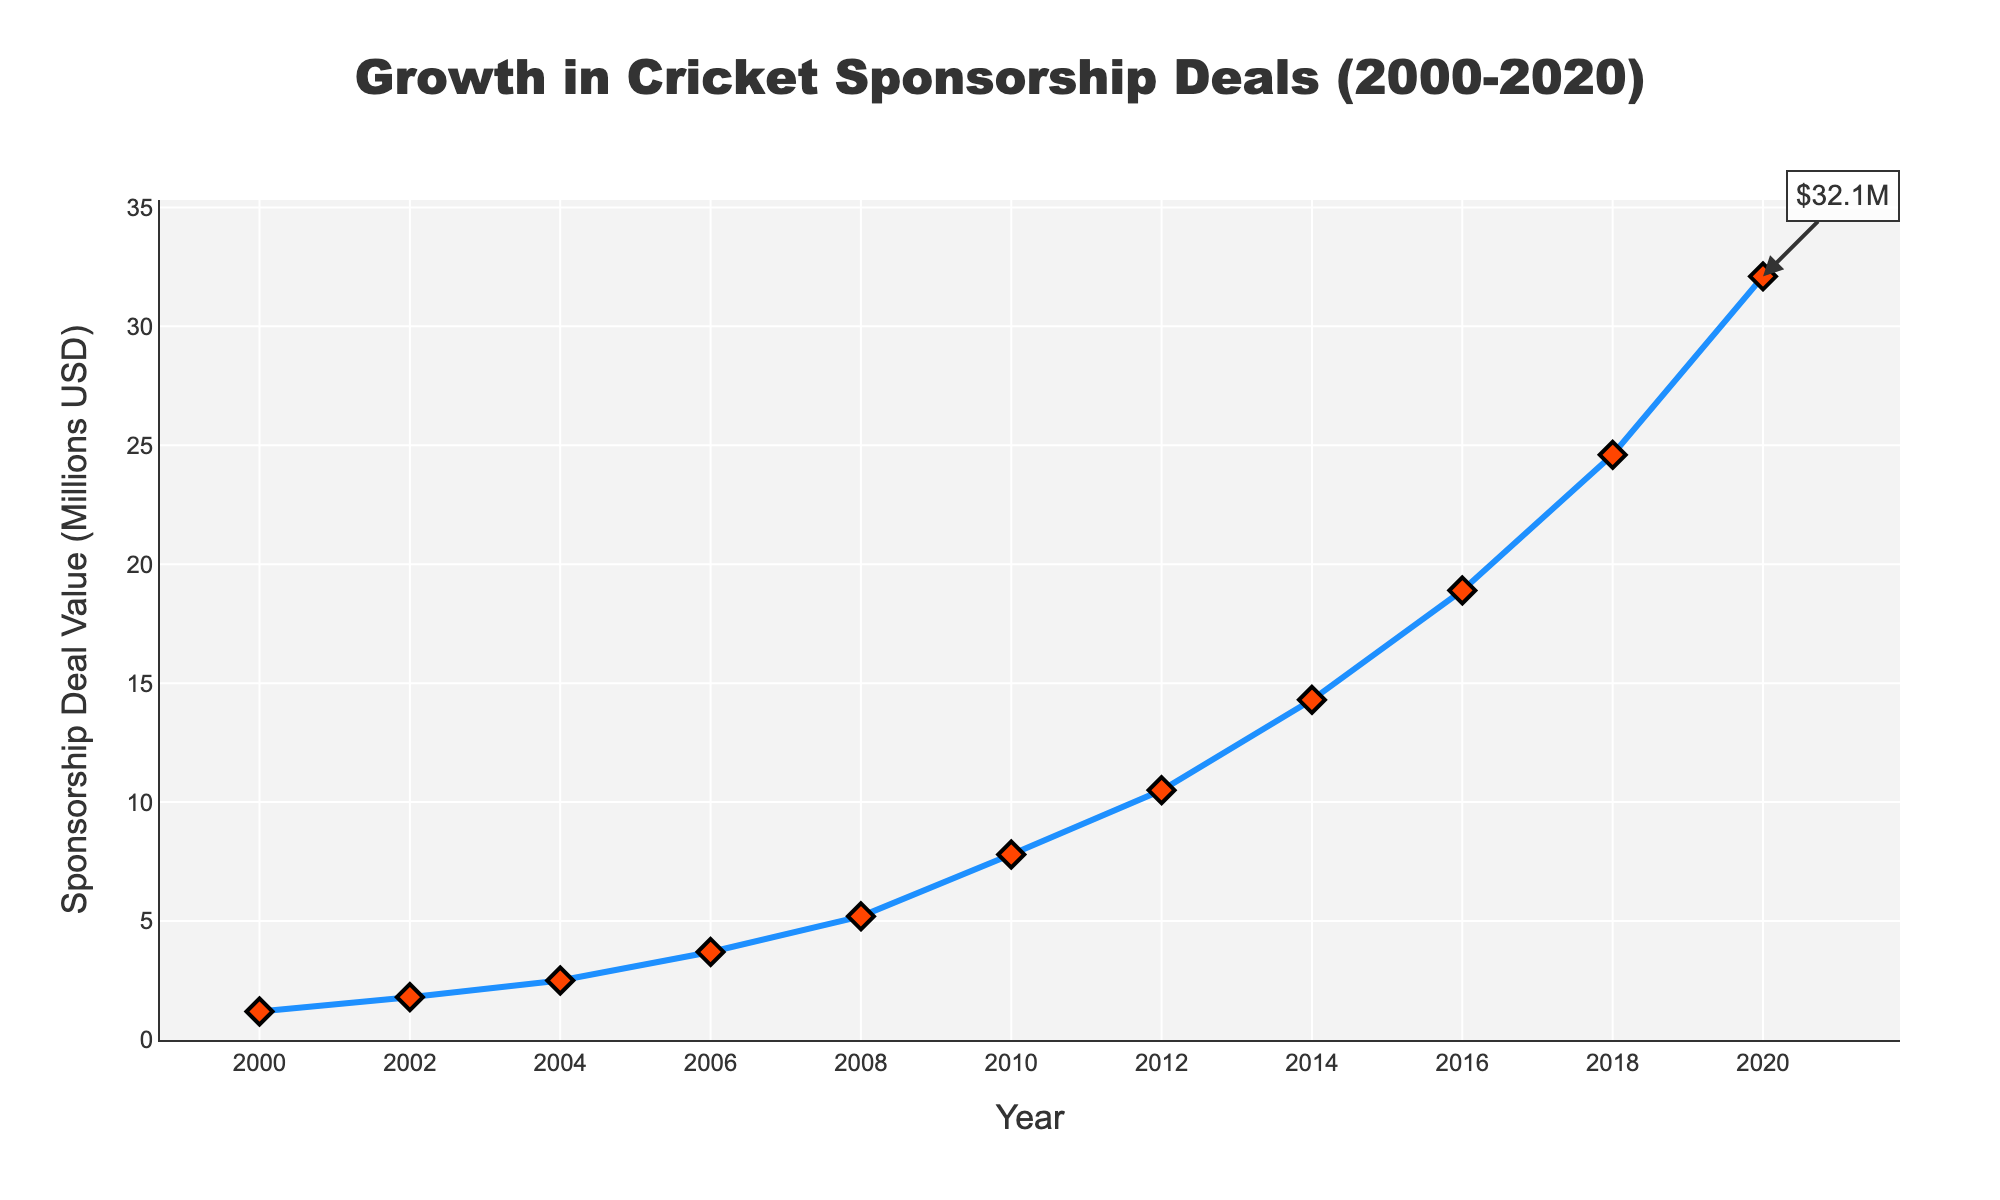What is the value of the sponsorship deals in 2008 and how does it compare to 2010? In 2008, the value of the sponsorship deals is $5.2M. In 2010, it is $7.8M. Comparing these, the sponsorship deals value increased by $2.6M from 2008 to 2010.
Answer: In 2008: $5.2M, In 2010: $7.8M, Increase by $2.6M What was the total growth in sponsorship deal value from 2000 to 2020? The value in 2000 was $1.2M and in 2020 it was $32.1M. The total growth is calculated by subtracting the 2000 value from the 2020 value: $32.1M - $1.2M = $30.9M.
Answer: $30.9M What is the average annual increase in sponsorship deal value between 2000 and 2020? First, calculate the total increase, which is $30.9M, and then divide it by the number of years (2020 - 2000 = 20 years). The average annual increase is $30.9M / 20 years = $1.545M per year.
Answer: $1.545M per year How does the sponsorship deal value in 2016 compare to the previous four years combined? The value in 2016 was $18.9M. The combined value of the four previous years (2012 and 2014 only, as data is biennial) is $10.5M (2012) + $14.3M (2014) = $24.8M. The value in 2016 is less than the combined values of the previous four years.
Answer: 2016: $18.9M, Previous four years combined: $24.8M, 2016 is less Which year saw the highest growth in sponsorship deal value, and what was the value increase? The highest growth is observed between 2018 ($24.6M) and 2020 ($32.1M). The value increase is $32.1M - $24.6M = $7.5M.
Answer: 2018-2020, $7.5M What was the percentage increase in sponsorship deal value from 2014 to 2016? The value in 2014 was $14.3M and in 2016 it was $18.9M. The percentage increase is calculated as (($18.9M - $14.3M) / $14.3M) * 100 = 32.17%.
Answer: 32.17% Would you say the sponsorship deal value grew more consistently in the first decade (2000-2010) or the second decade (2010-2020)? In the first decade, the values grew from $1.2M in 2000 to $7.8M in 2010, a difference of $6.6M over 10 years. In the second decade, the values grew from $7.8M in 2010 to $32.1M in 2020, a difference of $24.3M. The second decade shows a more significant and consistent growth.
Answer: Second decade, $24.3M What is the median sponsorship deal value over the 20-year period? The median sponsorship deal value is the middle value when the data points are ordered. The ordered values are: 1.2, 1.8, 2.5, 3.7, 5.2, 7.8, 10.5, 14.3, 18.9, 24.6, 32.1. As there is an odd number of data points (11), the median value is the 6th one: $7.8M.
Answer: $7.8M 